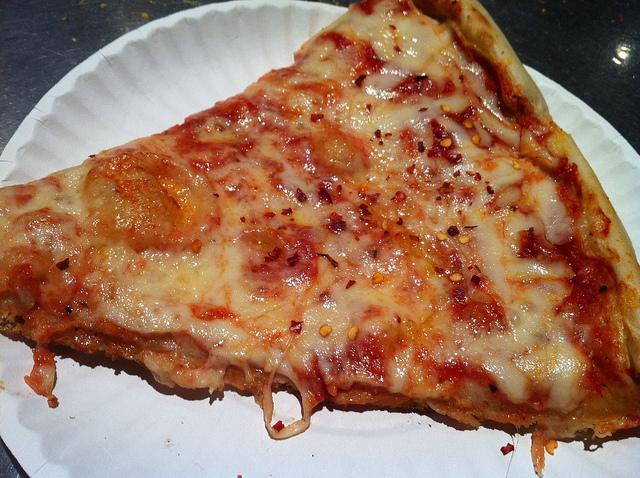What kind of crust does the pizza have?
Be succinct. Thin. What topping is on the pizza?
Quick response, please. Cheese. Is this served on fine China?
Give a very brief answer. No. 